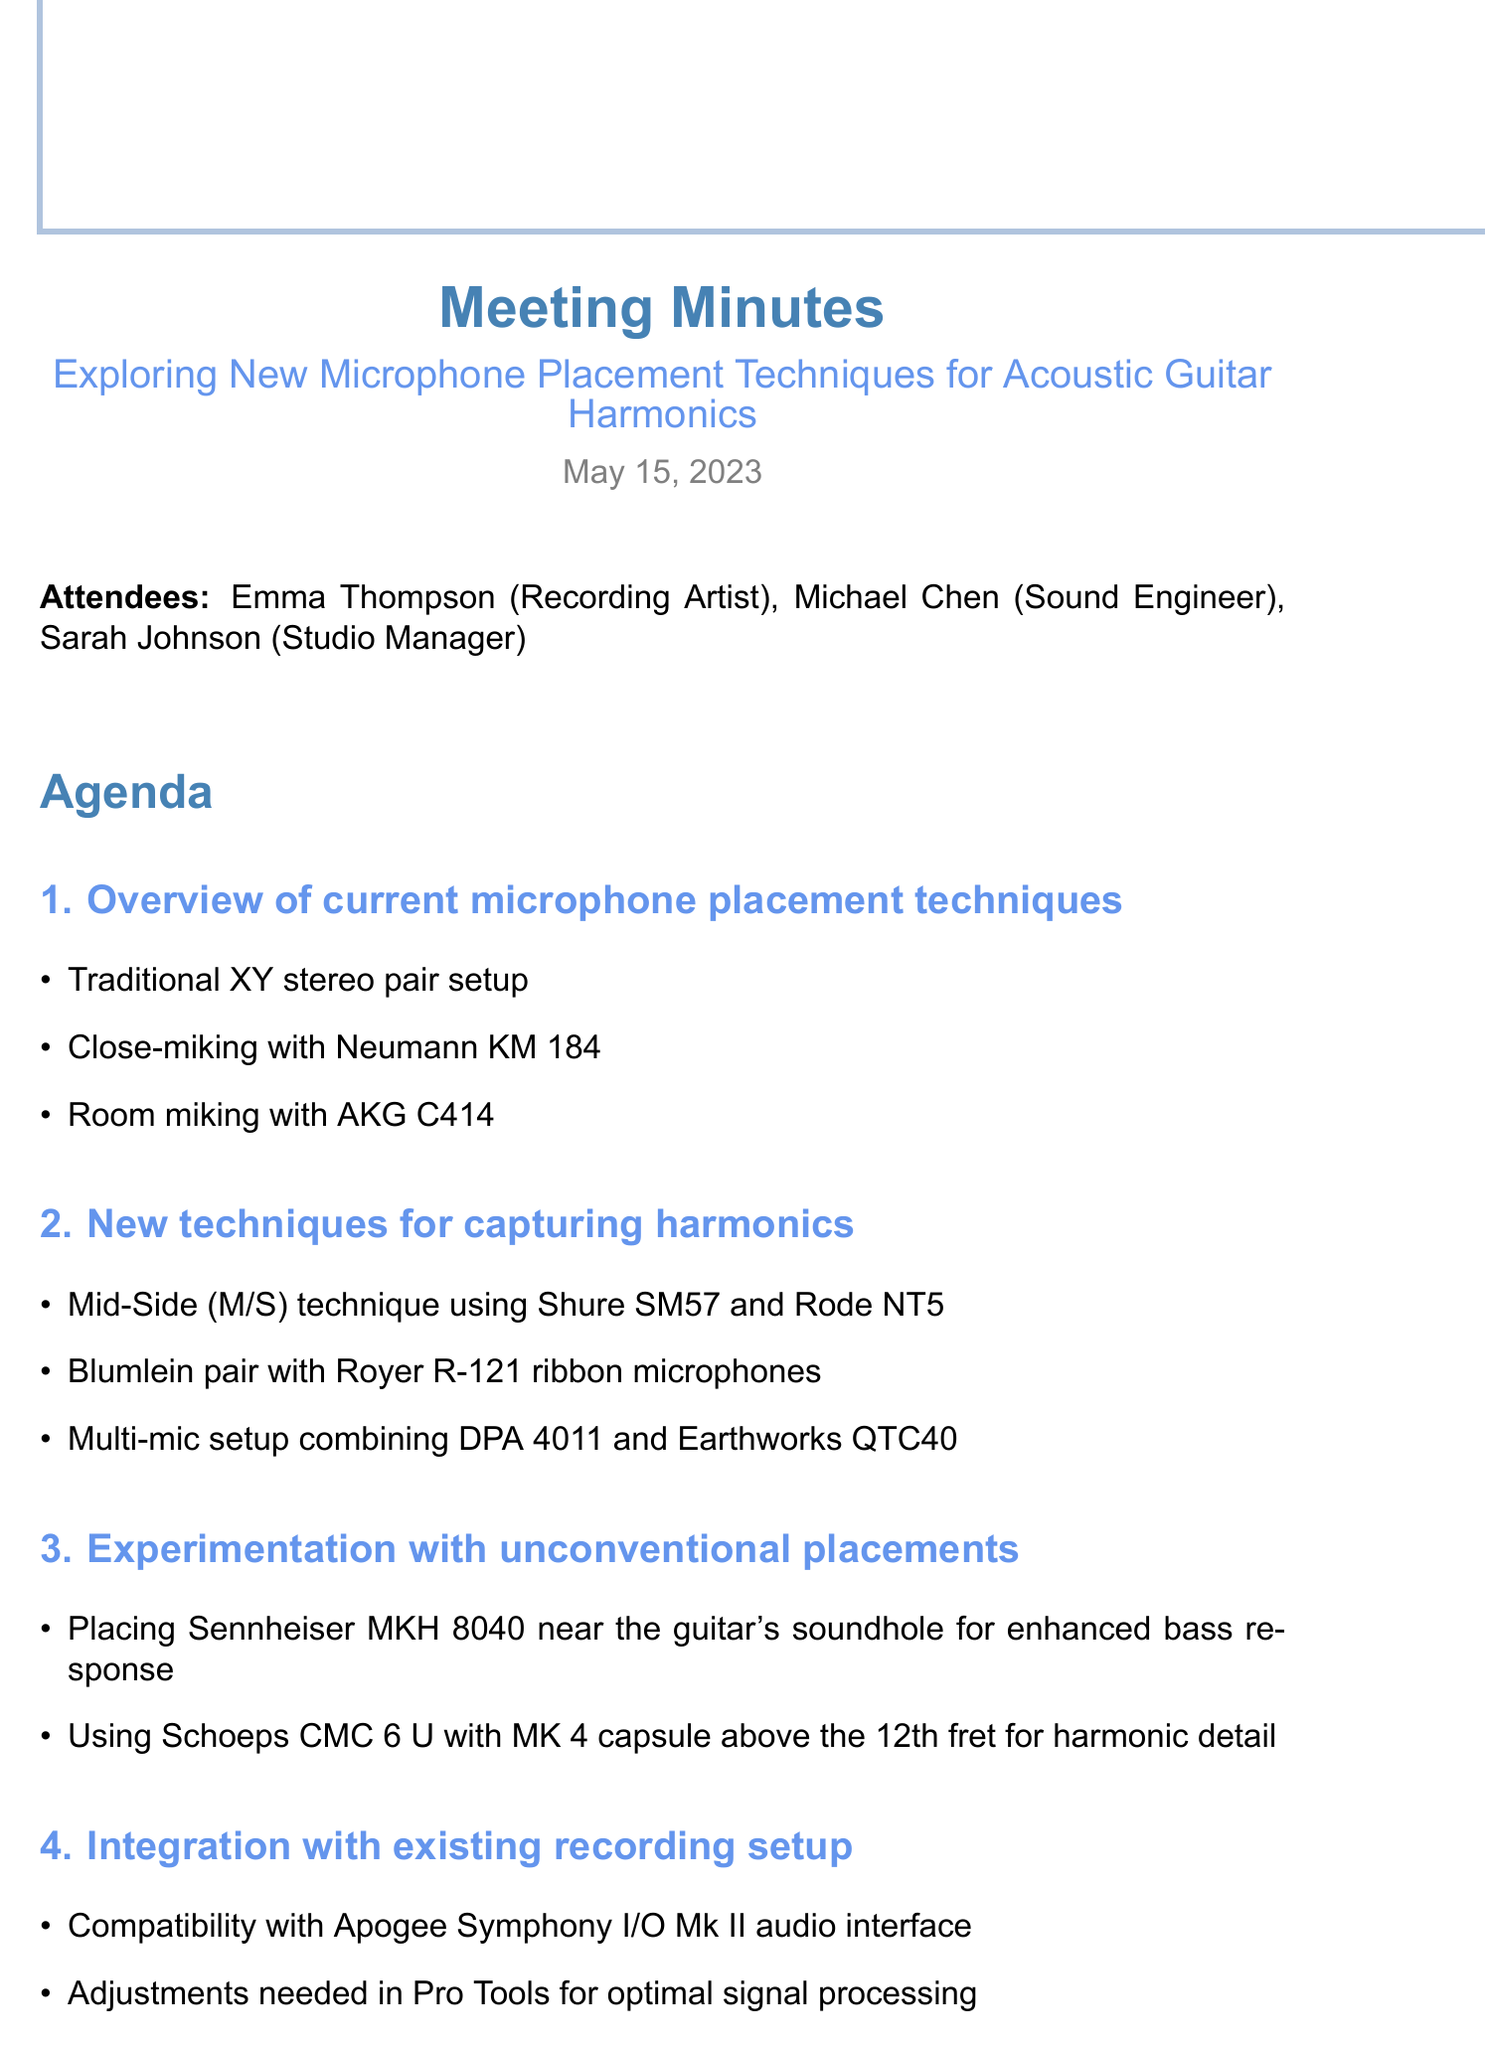What is the date of the meeting? The date of the meeting is listed under the title in the document.
Answer: May 15, 2023 Who is the sound engineer present in the meeting? The attendees list includes names and roles, allowing identification of the sound engineer.
Answer: Michael Chen What microphone is suggested for the Mid-Side technique? The agenda item discussing new techniques specifies which microphones are to be used in the Mid-Side technique.
Answer: Shure SM57 and Rode NT5 What unconventional placement is suggested for enhanced bass response? The experimentation section includes details about unconventional placements for microphones, including one that enhances bass.
Answer: Near the guitar's soundhole Which audio interface is mentioned for compatibility? The integration section discusses compatibility with existing equipment, including the specific audio interface mentioned.
Answer: Apogee Symphony I/O Mk II What is the first item on the agenda? The agenda items are numbered, indicating a specific order for discussion topics.
Answer: Overview of current microphone placement techniques How many attendees were present at the meeting? The attendees list provides the number of individuals participating in the meeting.
Answer: Three What is one of the next steps mentioned in the meeting? The next steps section summarizes actions to be taken following the meeting, capturing future plans.
Answer: Schedule recording session to test new techniques 